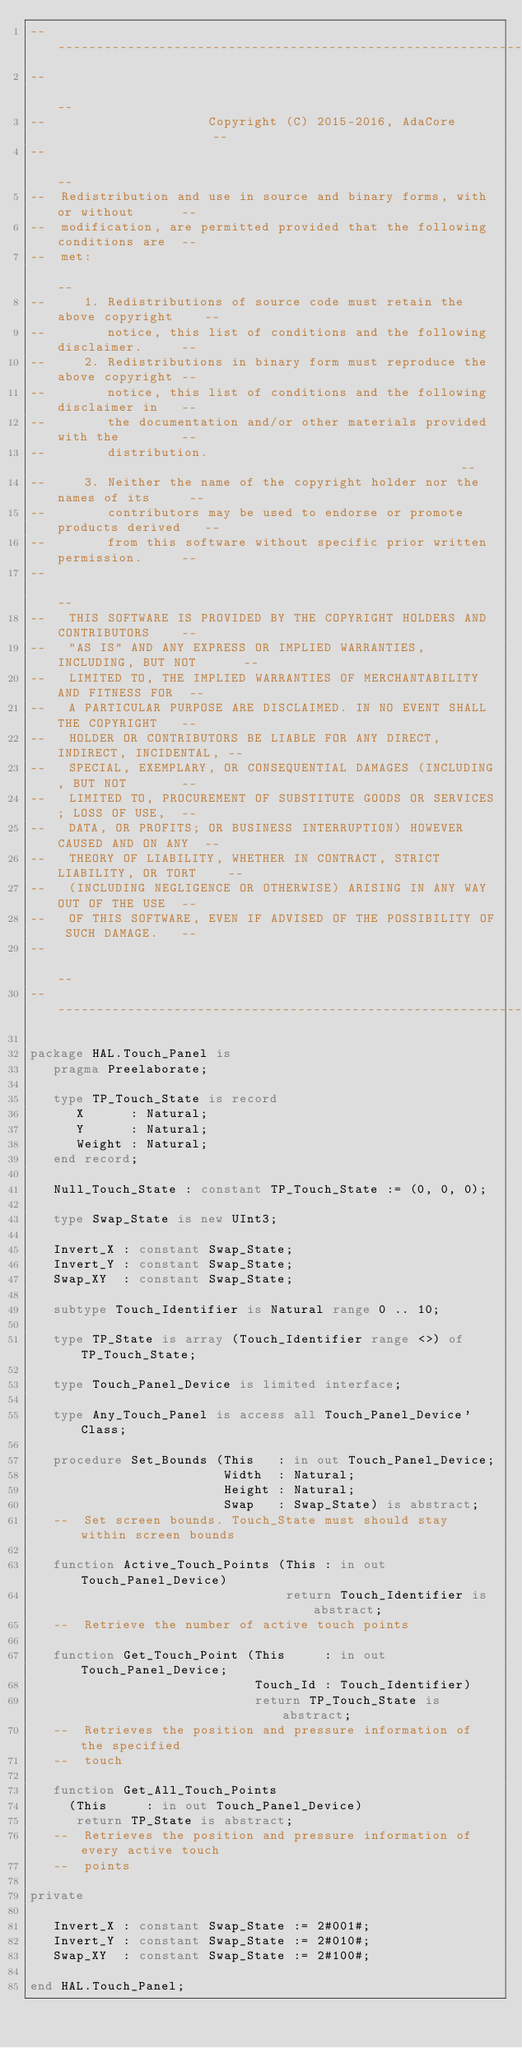Convert code to text. <code><loc_0><loc_0><loc_500><loc_500><_Ada_>------------------------------------------------------------------------------
--                                                                          --
--                     Copyright (C) 2015-2016, AdaCore                     --
--                                                                          --
--  Redistribution and use in source and binary forms, with or without      --
--  modification, are permitted provided that the following conditions are  --
--  met:                                                                    --
--     1. Redistributions of source code must retain the above copyright    --
--        notice, this list of conditions and the following disclaimer.     --
--     2. Redistributions in binary form must reproduce the above copyright --
--        notice, this list of conditions and the following disclaimer in   --
--        the documentation and/or other materials provided with the        --
--        distribution.                                                     --
--     3. Neither the name of the copyright holder nor the names of its     --
--        contributors may be used to endorse or promote products derived   --
--        from this software without specific prior written permission.     --
--                                                                          --
--   THIS SOFTWARE IS PROVIDED BY THE COPYRIGHT HOLDERS AND CONTRIBUTORS    --
--   "AS IS" AND ANY EXPRESS OR IMPLIED WARRANTIES, INCLUDING, BUT NOT      --
--   LIMITED TO, THE IMPLIED WARRANTIES OF MERCHANTABILITY AND FITNESS FOR  --
--   A PARTICULAR PURPOSE ARE DISCLAIMED. IN NO EVENT SHALL THE COPYRIGHT   --
--   HOLDER OR CONTRIBUTORS BE LIABLE FOR ANY DIRECT, INDIRECT, INCIDENTAL, --
--   SPECIAL, EXEMPLARY, OR CONSEQUENTIAL DAMAGES (INCLUDING, BUT NOT       --
--   LIMITED TO, PROCUREMENT OF SUBSTITUTE GOODS OR SERVICES; LOSS OF USE,  --
--   DATA, OR PROFITS; OR BUSINESS INTERRUPTION) HOWEVER CAUSED AND ON ANY  --
--   THEORY OF LIABILITY, WHETHER IN CONTRACT, STRICT LIABILITY, OR TORT    --
--   (INCLUDING NEGLIGENCE OR OTHERWISE) ARISING IN ANY WAY OUT OF THE USE  --
--   OF THIS SOFTWARE, EVEN IF ADVISED OF THE POSSIBILITY OF SUCH DAMAGE.   --
--                                                                          --
------------------------------------------------------------------------------

package HAL.Touch_Panel is
   pragma Preelaborate;

   type TP_Touch_State is record
      X      : Natural;
      Y      : Natural;
      Weight : Natural;
   end record;

   Null_Touch_State : constant TP_Touch_State := (0, 0, 0);

   type Swap_State is new UInt3;

   Invert_X : constant Swap_State;
   Invert_Y : constant Swap_State;
   Swap_XY  : constant Swap_State;

   subtype Touch_Identifier is Natural range 0 .. 10;

   type TP_State is array (Touch_Identifier range <>) of TP_Touch_State;

   type Touch_Panel_Device is limited interface;

   type Any_Touch_Panel is access all Touch_Panel_Device'Class;

   procedure Set_Bounds (This   : in out Touch_Panel_Device;
                         Width  : Natural;
                         Height : Natural;
                         Swap   : Swap_State) is abstract;
   --  Set screen bounds. Touch_State must should stay within screen bounds

   function Active_Touch_Points (This : in out Touch_Panel_Device)
                                 return Touch_Identifier is abstract;
   --  Retrieve the number of active touch points

   function Get_Touch_Point (This     : in out Touch_Panel_Device;
                             Touch_Id : Touch_Identifier)
                             return TP_Touch_State is abstract;
   --  Retrieves the position and pressure information of the specified
   --  touch

   function Get_All_Touch_Points
     (This     : in out Touch_Panel_Device)
      return TP_State is abstract;
   --  Retrieves the position and pressure information of every active touch
   --  points

private

   Invert_X : constant Swap_State := 2#001#;
   Invert_Y : constant Swap_State := 2#010#;
   Swap_XY  : constant Swap_State := 2#100#;

end HAL.Touch_Panel;
</code> 